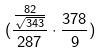<formula> <loc_0><loc_0><loc_500><loc_500>( \frac { \frac { 8 2 } { \sqrt { 3 4 3 } } } { 2 8 7 } \cdot \frac { 3 7 8 } { 9 } )</formula> 